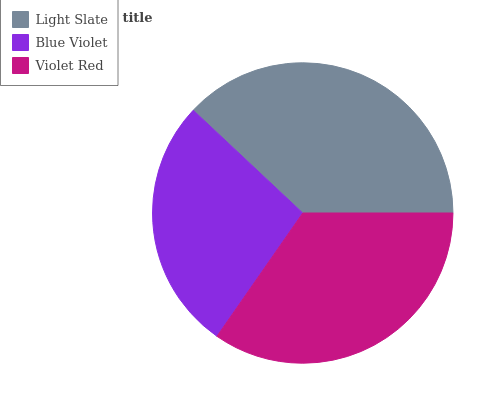Is Blue Violet the minimum?
Answer yes or no. Yes. Is Light Slate the maximum?
Answer yes or no. Yes. Is Violet Red the minimum?
Answer yes or no. No. Is Violet Red the maximum?
Answer yes or no. No. Is Violet Red greater than Blue Violet?
Answer yes or no. Yes. Is Blue Violet less than Violet Red?
Answer yes or no. Yes. Is Blue Violet greater than Violet Red?
Answer yes or no. No. Is Violet Red less than Blue Violet?
Answer yes or no. No. Is Violet Red the high median?
Answer yes or no. Yes. Is Violet Red the low median?
Answer yes or no. Yes. Is Blue Violet the high median?
Answer yes or no. No. Is Light Slate the low median?
Answer yes or no. No. 